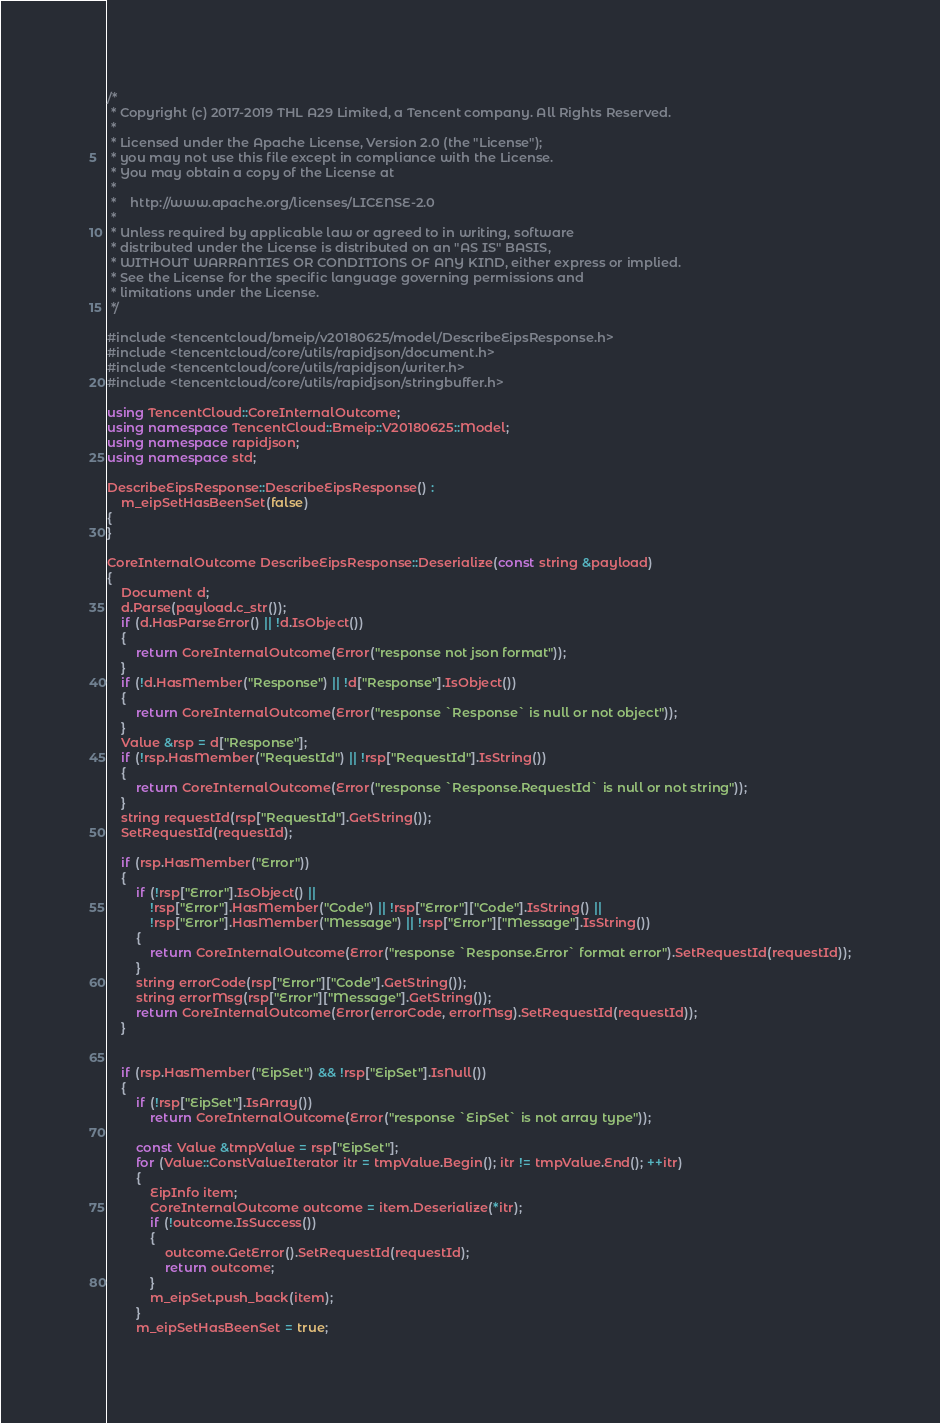<code> <loc_0><loc_0><loc_500><loc_500><_C++_>/*
 * Copyright (c) 2017-2019 THL A29 Limited, a Tencent company. All Rights Reserved.
 *
 * Licensed under the Apache License, Version 2.0 (the "License");
 * you may not use this file except in compliance with the License.
 * You may obtain a copy of the License at
 *
 *    http://www.apache.org/licenses/LICENSE-2.0
 *
 * Unless required by applicable law or agreed to in writing, software
 * distributed under the License is distributed on an "AS IS" BASIS,
 * WITHOUT WARRANTIES OR CONDITIONS OF ANY KIND, either express or implied.
 * See the License for the specific language governing permissions and
 * limitations under the License.
 */

#include <tencentcloud/bmeip/v20180625/model/DescribeEipsResponse.h>
#include <tencentcloud/core/utils/rapidjson/document.h>
#include <tencentcloud/core/utils/rapidjson/writer.h>
#include <tencentcloud/core/utils/rapidjson/stringbuffer.h>

using TencentCloud::CoreInternalOutcome;
using namespace TencentCloud::Bmeip::V20180625::Model;
using namespace rapidjson;
using namespace std;

DescribeEipsResponse::DescribeEipsResponse() :
    m_eipSetHasBeenSet(false)
{
}

CoreInternalOutcome DescribeEipsResponse::Deserialize(const string &payload)
{
    Document d;
    d.Parse(payload.c_str());
    if (d.HasParseError() || !d.IsObject())
    {
        return CoreInternalOutcome(Error("response not json format"));
    }
    if (!d.HasMember("Response") || !d["Response"].IsObject())
    {
        return CoreInternalOutcome(Error("response `Response` is null or not object"));
    }
    Value &rsp = d["Response"];
    if (!rsp.HasMember("RequestId") || !rsp["RequestId"].IsString())
    {
        return CoreInternalOutcome(Error("response `Response.RequestId` is null or not string"));
    }
    string requestId(rsp["RequestId"].GetString());
    SetRequestId(requestId);

    if (rsp.HasMember("Error"))
    {
        if (!rsp["Error"].IsObject() ||
            !rsp["Error"].HasMember("Code") || !rsp["Error"]["Code"].IsString() ||
            !rsp["Error"].HasMember("Message") || !rsp["Error"]["Message"].IsString())
        {
            return CoreInternalOutcome(Error("response `Response.Error` format error").SetRequestId(requestId));
        }
        string errorCode(rsp["Error"]["Code"].GetString());
        string errorMsg(rsp["Error"]["Message"].GetString());
        return CoreInternalOutcome(Error(errorCode, errorMsg).SetRequestId(requestId));
    }


    if (rsp.HasMember("EipSet") && !rsp["EipSet"].IsNull())
    {
        if (!rsp["EipSet"].IsArray())
            return CoreInternalOutcome(Error("response `EipSet` is not array type"));

        const Value &tmpValue = rsp["EipSet"];
        for (Value::ConstValueIterator itr = tmpValue.Begin(); itr != tmpValue.End(); ++itr)
        {
            EipInfo item;
            CoreInternalOutcome outcome = item.Deserialize(*itr);
            if (!outcome.IsSuccess())
            {
                outcome.GetError().SetRequestId(requestId);
                return outcome;
            }
            m_eipSet.push_back(item);
        }
        m_eipSetHasBeenSet = true;</code> 